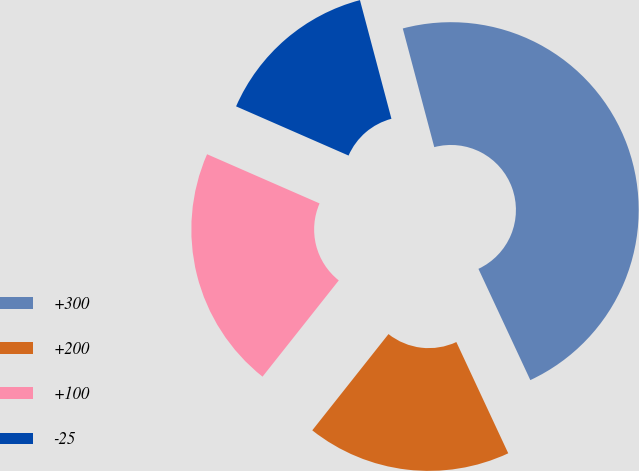Convert chart. <chart><loc_0><loc_0><loc_500><loc_500><pie_chart><fcel>+300<fcel>+200<fcel>+100<fcel>-25<nl><fcel>47.18%<fcel>17.61%<fcel>20.9%<fcel>14.31%<nl></chart> 